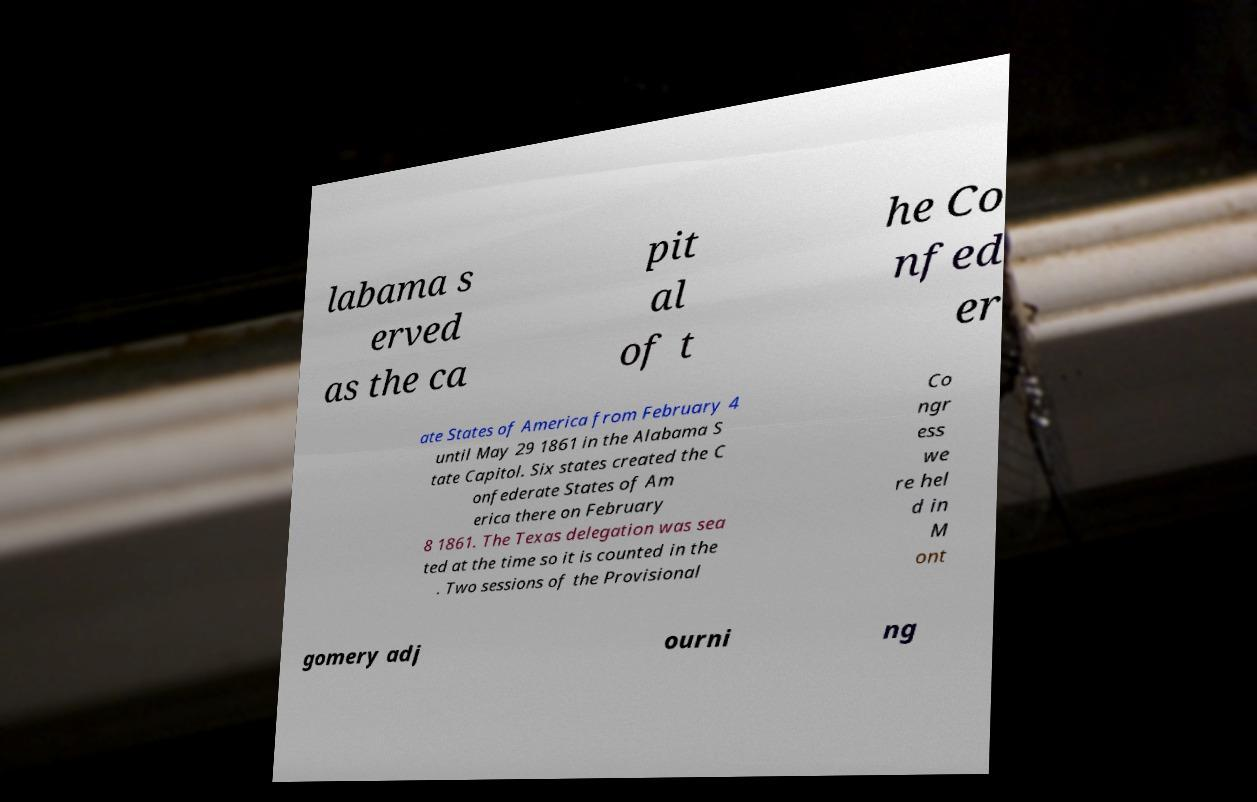Could you assist in decoding the text presented in this image and type it out clearly? labama s erved as the ca pit al of t he Co nfed er ate States of America from February 4 until May 29 1861 in the Alabama S tate Capitol. Six states created the C onfederate States of Am erica there on February 8 1861. The Texas delegation was sea ted at the time so it is counted in the . Two sessions of the Provisional Co ngr ess we re hel d in M ont gomery adj ourni ng 